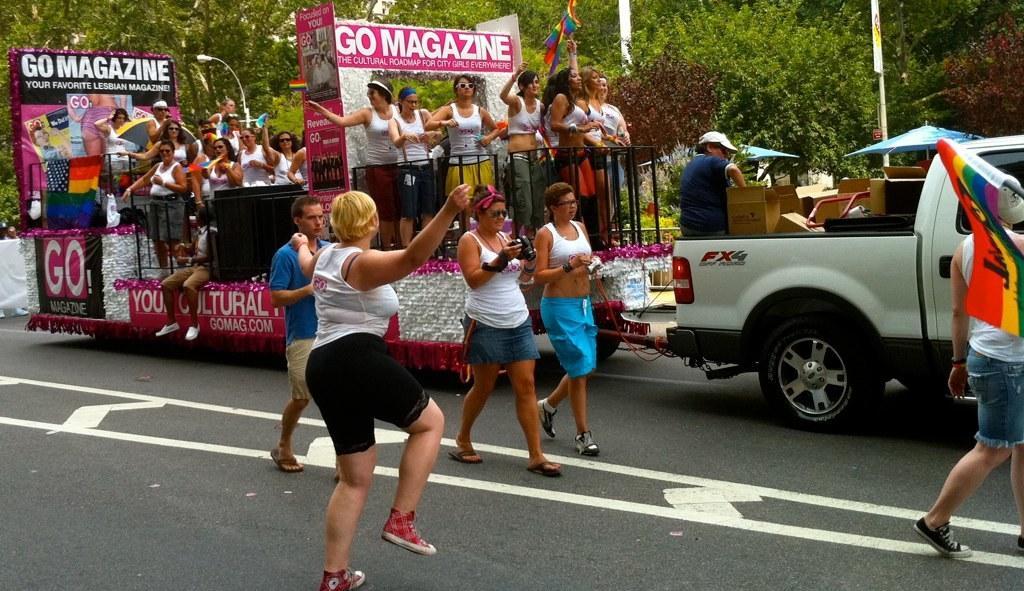Please provide a concise description of this image. In this image I can see road and on it I can see white lines and a vehicle. I can also see number of people where few are standing on road and few are standing in background. I can also see something is written at few places and I can also see number of trees in background. 